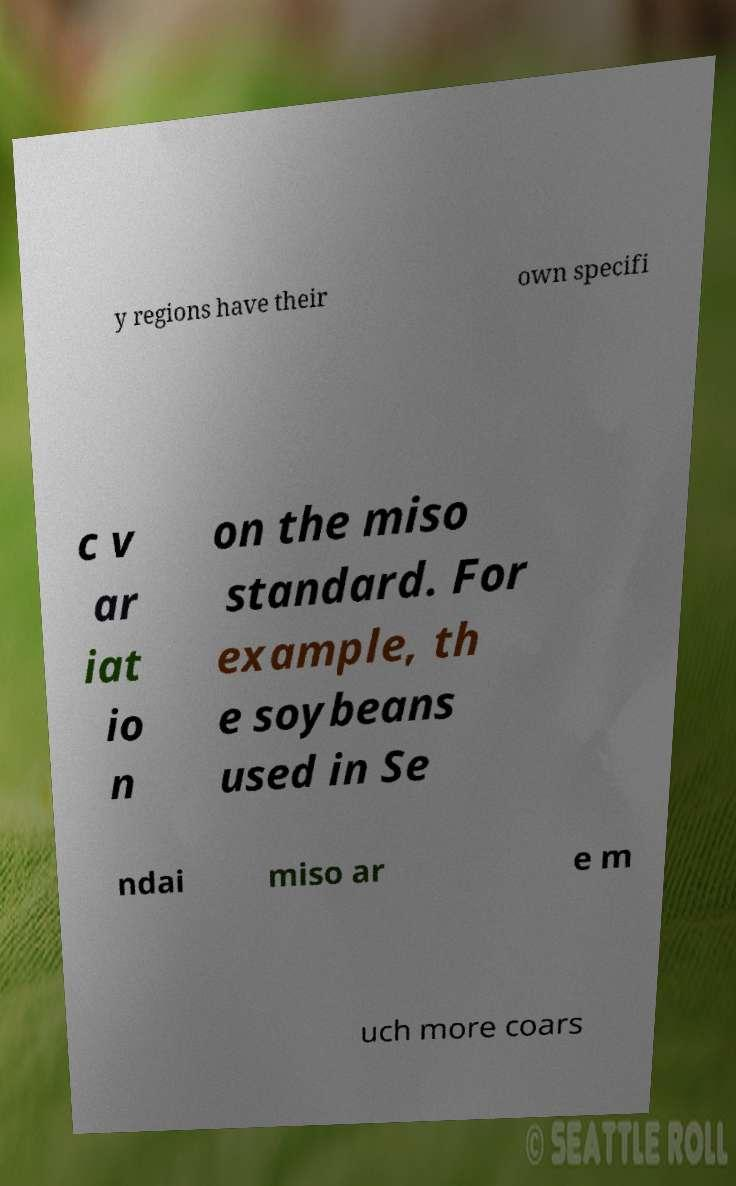Could you extract and type out the text from this image? y regions have their own specifi c v ar iat io n on the miso standard. For example, th e soybeans used in Se ndai miso ar e m uch more coars 